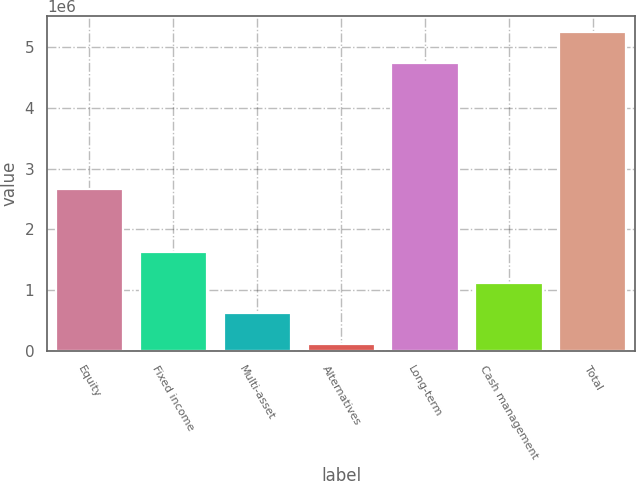<chart> <loc_0><loc_0><loc_500><loc_500><bar_chart><fcel>Equity<fcel>Fixed income<fcel>Multi-asset<fcel>Alternatives<fcel>Long-term<fcel>Cash management<fcel>Total<nl><fcel>2.65718e+06<fcel>1.62621e+06<fcel>620029<fcel>116938<fcel>4.74149e+06<fcel>1.12312e+06<fcel>5.24458e+06<nl></chart> 